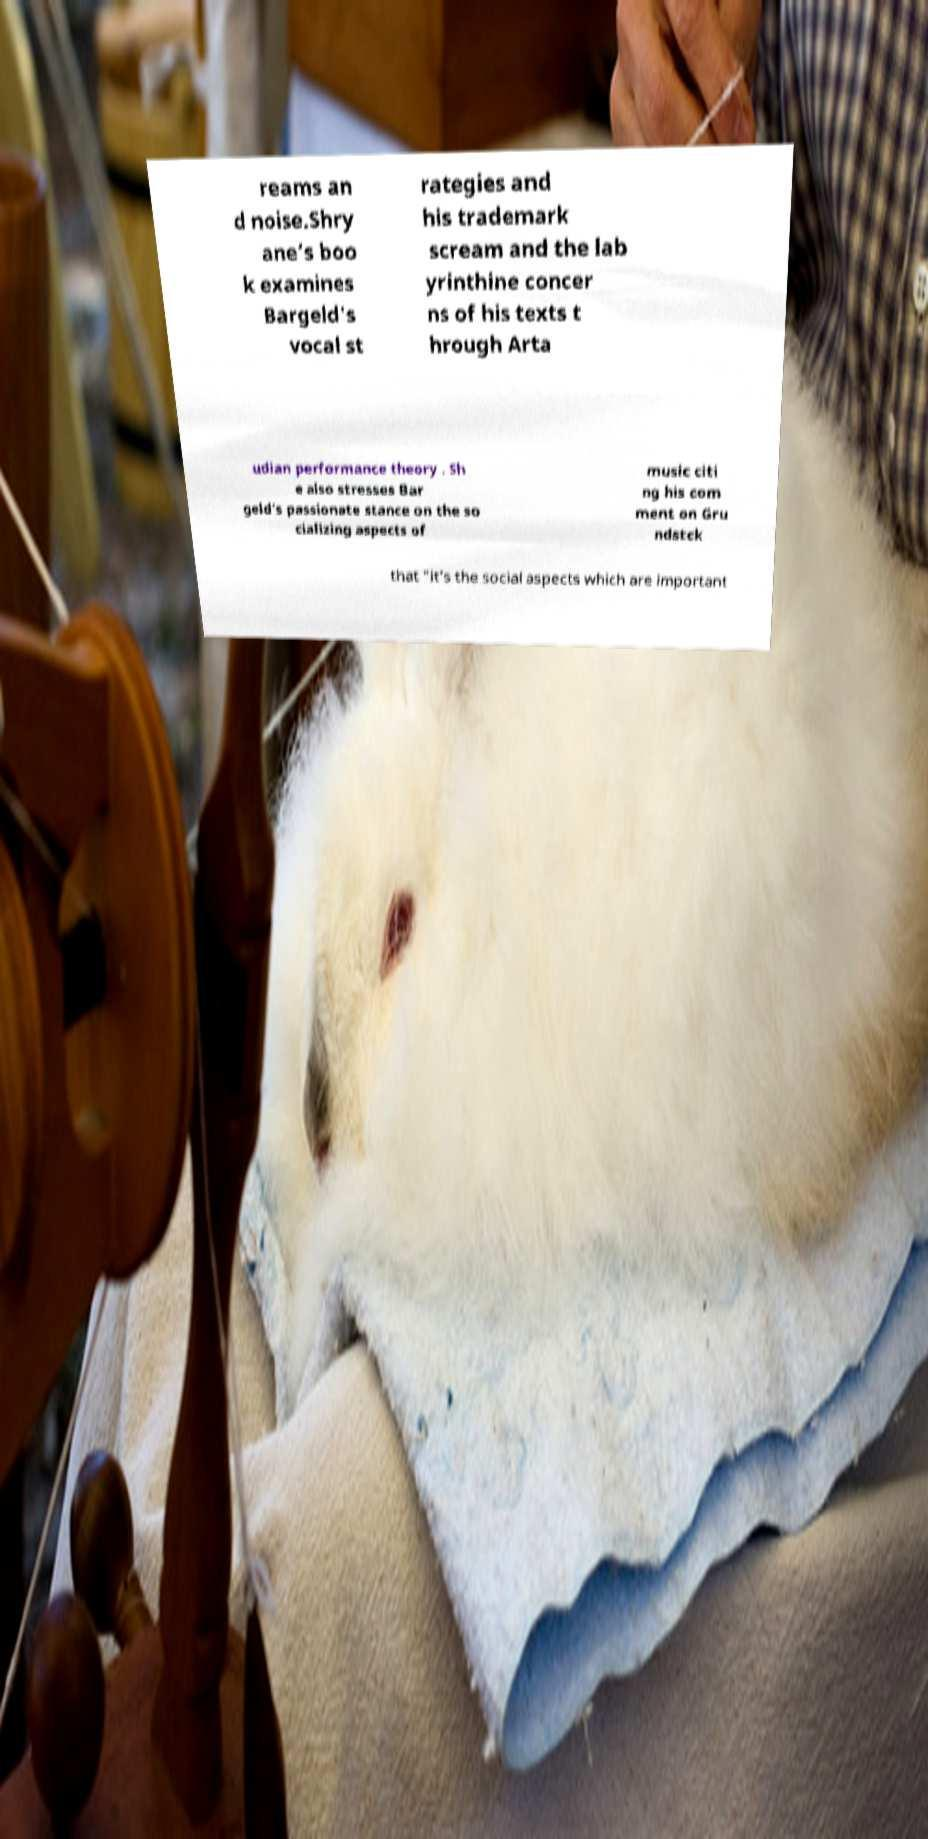I need the written content from this picture converted into text. Can you do that? reams an d noise.Shry ane’s boo k examines Bargeld's vocal st rategies and his trademark scream and the lab yrinthine concer ns of his texts t hrough Arta udian performance theory . Sh e also stresses Bar geld’s passionate stance on the so cializing aspects of music citi ng his com ment on Gru ndstck that "it’s the social aspects which are important 